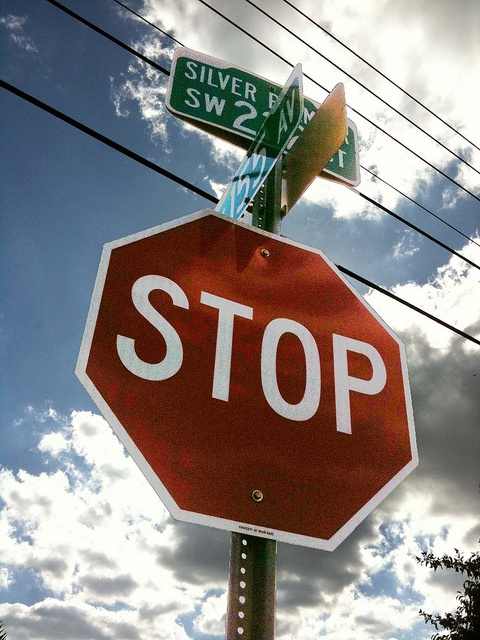Describe the objects in this image and their specific colors. I can see a stop sign in navy, maroon, and darkgray tones in this image. 